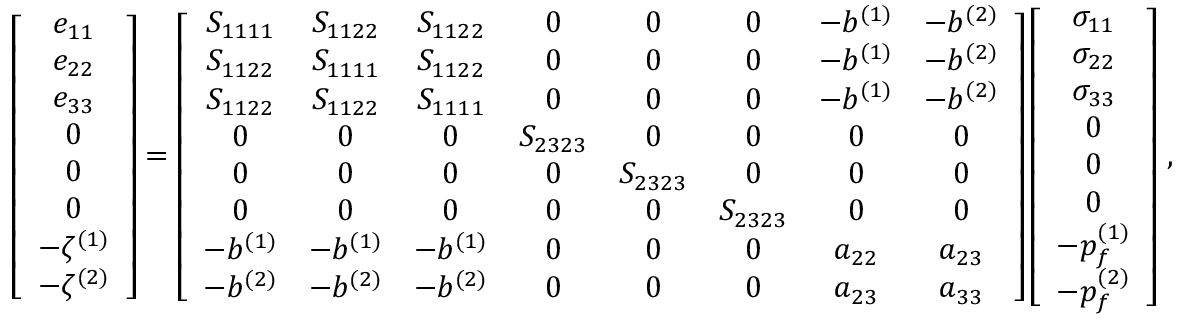<formula> <loc_0><loc_0><loc_500><loc_500>\left [ \begin{array} { c } { e _ { 1 1 } } \\ { e _ { 2 2 } } \\ { e _ { 3 3 } } \\ { 0 } \\ { 0 } \\ { 0 } \\ { - \zeta ^ { ( 1 ) } } \\ { - \zeta ^ { ( 2 ) } } \end{array} \right ] = \left [ \begin{array} { c c c c c c c c } { S _ { 1 1 1 1 } } & { S _ { 1 1 2 2 } } & { S _ { 1 1 2 2 } } & { 0 } & { 0 } & { 0 } & { - b ^ { ( 1 ) } } & { - b ^ { ( 2 ) } } \\ { S _ { 1 1 2 2 } } & { S _ { 1 1 1 1 } } & { S _ { 1 1 2 2 } } & { 0 } & { 0 } & { 0 } & { - b ^ { ( 1 ) } } & { - b ^ { ( 2 ) } } \\ { S _ { 1 1 2 2 } } & { S _ { 1 1 2 2 } } & { S _ { 1 1 1 1 } } & { 0 } & { 0 } & { 0 } & { - b ^ { ( 1 ) } } & { - b ^ { ( 2 ) } } \\ { 0 } & { 0 } & { 0 } & { S _ { 2 3 2 3 } } & { 0 } & { 0 } & { 0 } & { 0 } \\ { 0 } & { 0 } & { 0 } & { 0 } & { S _ { 2 3 2 3 } } & { 0 } & { 0 } & { 0 } \\ { 0 } & { 0 } & { 0 } & { 0 } & { 0 } & { S _ { 2 3 2 3 } } & { 0 } & { 0 } \\ { - b ^ { ( 1 ) } } & { - b ^ { ( 1 ) } } & { - b ^ { ( 1 ) } } & { 0 } & { 0 } & { 0 } & { a _ { 2 2 } } & { a _ { 2 3 } } \\ { - b ^ { ( 2 ) } } & { - b ^ { ( 2 ) } } & { - b ^ { ( 2 ) } } & { 0 } & { 0 } & { 0 } & { a _ { 2 3 } } & { a _ { 3 3 } } \end{array} \right ] \left [ \begin{array} { c } { \sigma _ { 1 1 } } \\ { \sigma _ { 2 2 } } \\ { \sigma _ { 3 3 } } \\ { 0 } \\ { 0 } \\ { 0 } \\ { - p _ { f } ^ { ( 1 ) } } \\ { - p _ { f } ^ { ( 2 ) } } \end{array} \right ] \, ,</formula> 